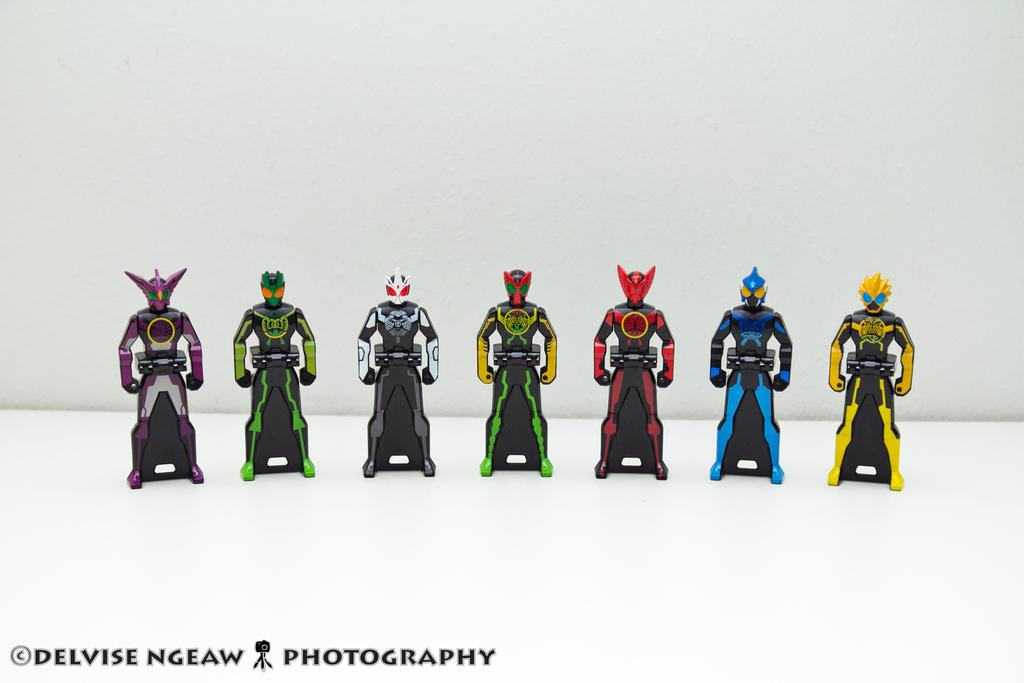What type of toys are in the image? There are power ranger toys in the image. Can you describe the appearance of the toys? The toys are in different colors. Is there any text present in the image? Yes, there is text at the bottom of the image, which is in black color. How many clovers can be seen growing in the image? There are no clovers present in the image. Is there a person interacting with the toys in the image? There is no person visible in the image; it only shows power ranger toys and text. 